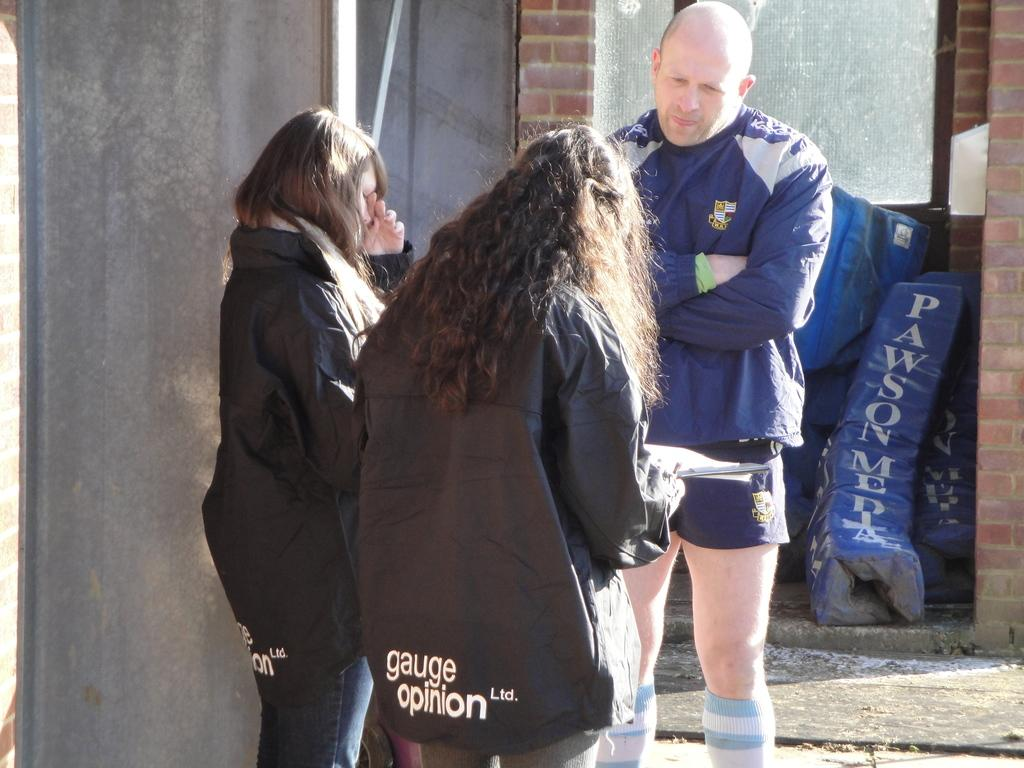Who or what is present in the image? There are people in the image. What are the people doing in the image? The people are talking. Where are the people located in the image? The people are in front of a wall. What might the people be carrying with them? The people are carrying bags. What type of song can be heard playing in the background of the image? There is no information about any song playing in the background of the image. 